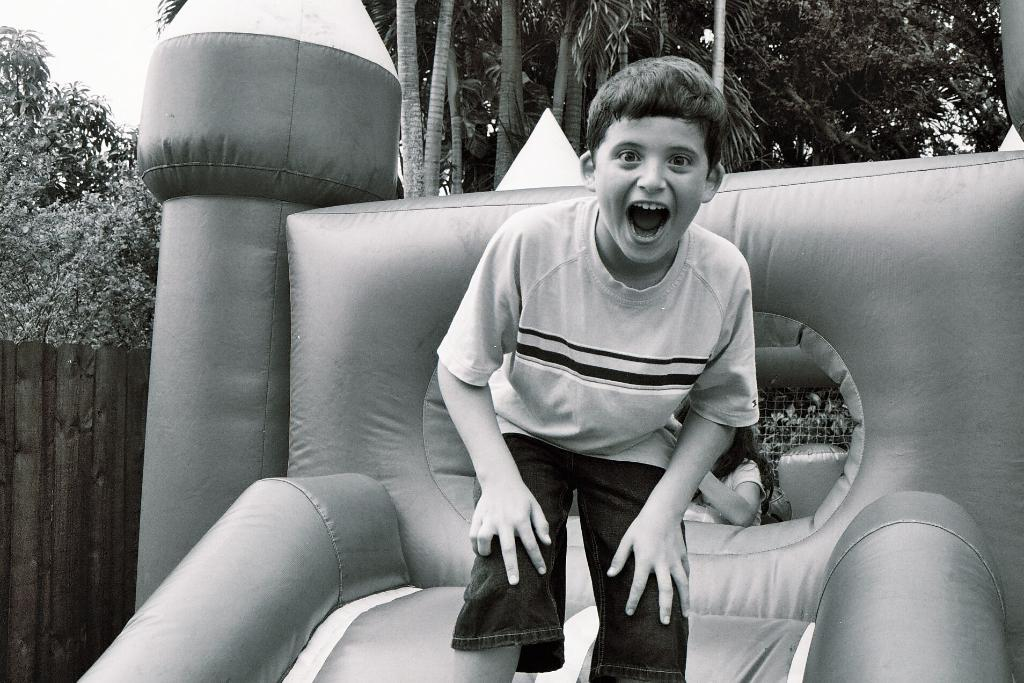What is the color scheme of the image? The image is black and white. Who is the main subject in the image? There is a boy in the image. What is the boy doing in the image? The boy is watching and smiling. What can be seen in the background of the image? There is an inflatable slide, a human, a grill, wooden fencing, and trees in the background. What type of polish is the boy applying to his leg in the image? There is no indication in the image that the boy is applying any polish to his leg. 